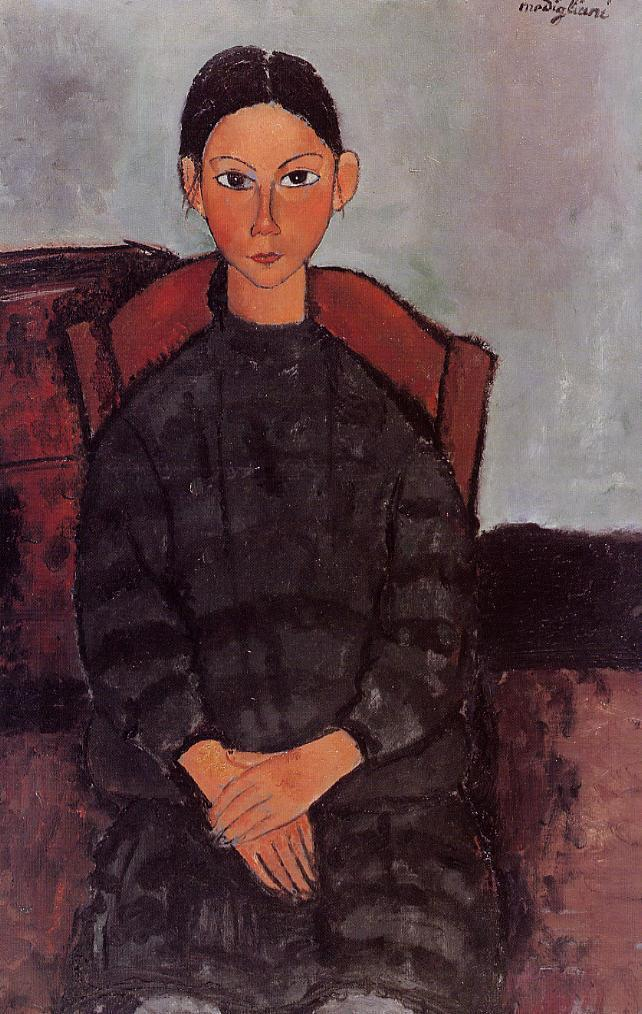How does the style of painting influence our understanding of the portrait? The style, with its simplified forms and bold outlines, is suggestive of the post-impressionist movement, which aimed to convey more emotion and meaning beyond the mere appearance of the subject. The deliberate abstraction of features, such as the elongated neck and the geometric treatment of the hands, steers the viewer to focus on the essence of the subject rather than her precise likeness. This stylistic choice elevates the subject, making her an archetype rather than an individual, thereby inviting a deeper engagement with the work's emotive and thematic elements. 